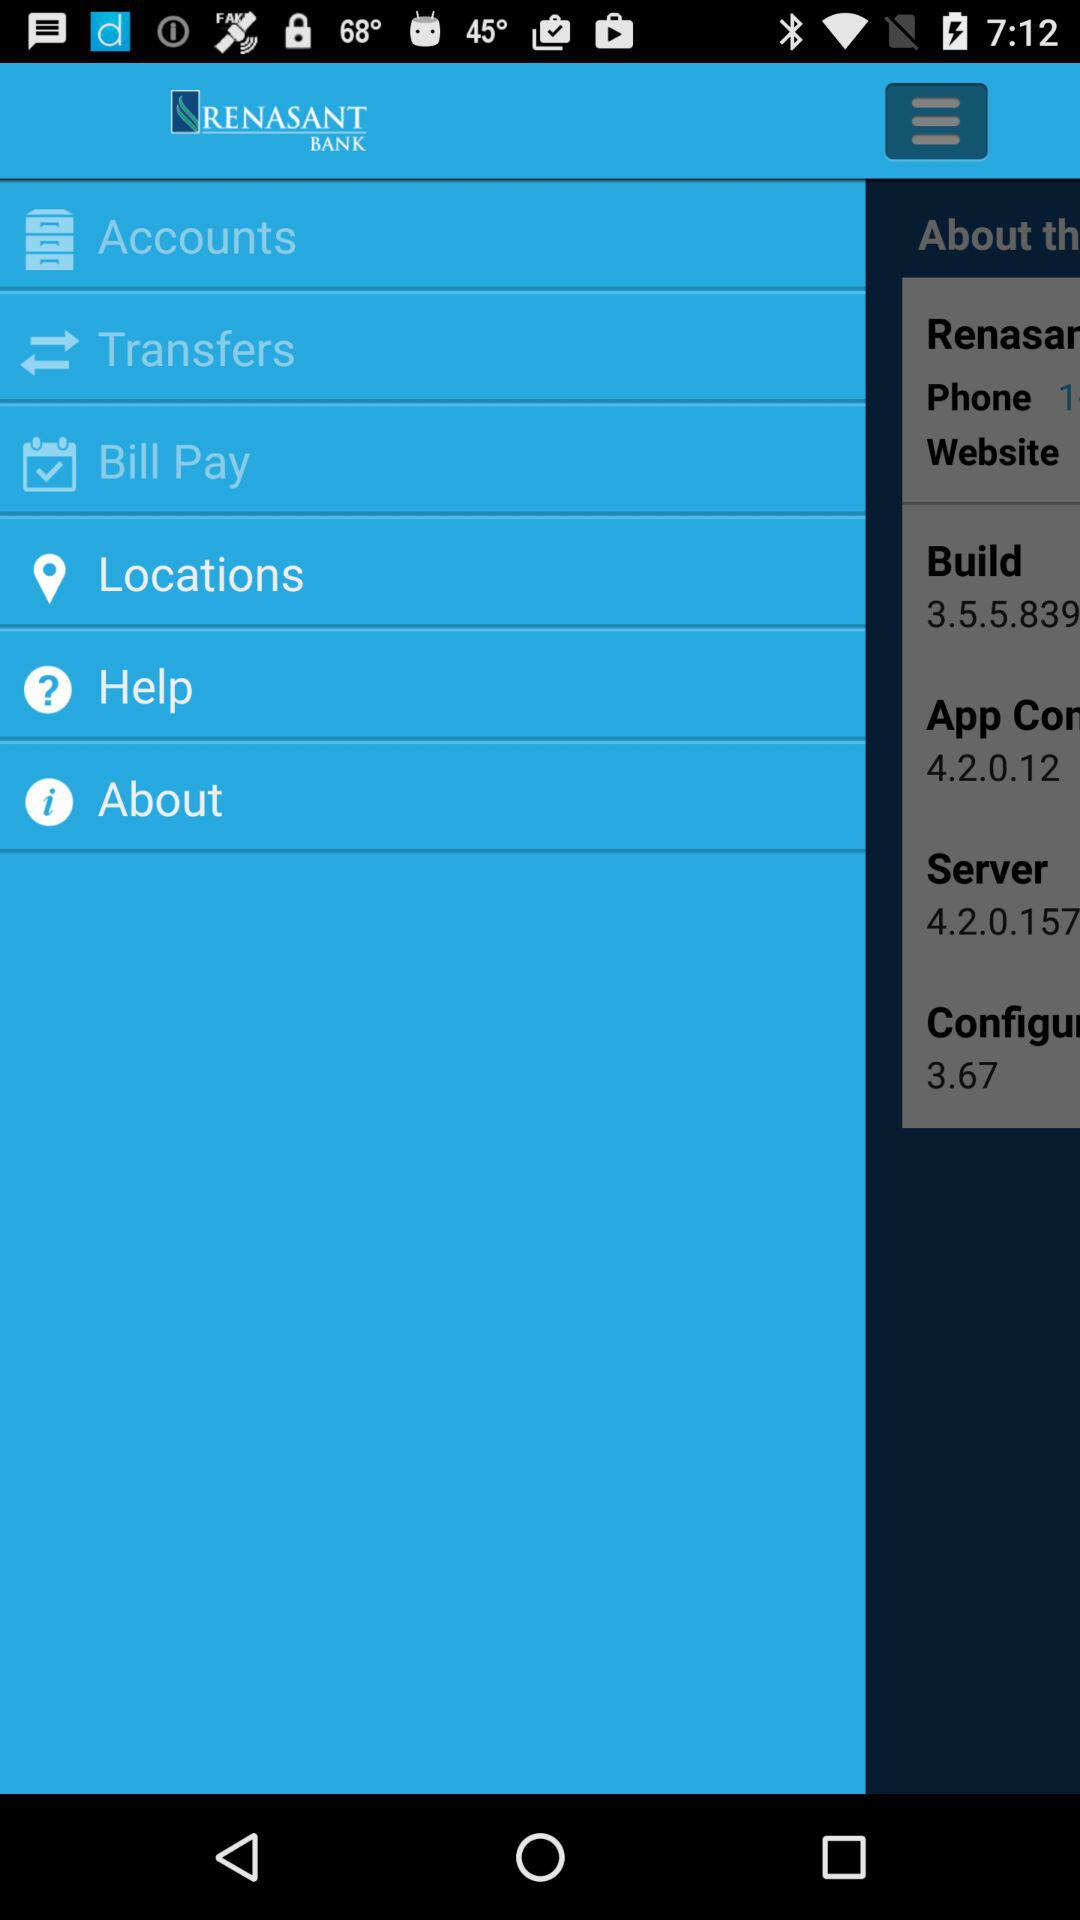What is the name of the application? The name of the application is "RENASANT BANK". 